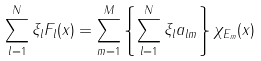Convert formula to latex. <formula><loc_0><loc_0><loc_500><loc_500>\sum _ { l = 1 } ^ { N } \xi _ { l } F _ { l } ( x ) = \sum _ { m = 1 } ^ { M } \left \{ \sum _ { l = 1 } ^ { N } \xi _ { l } a _ { l m } \right \} \chi _ { E _ { m } } ( x )</formula> 